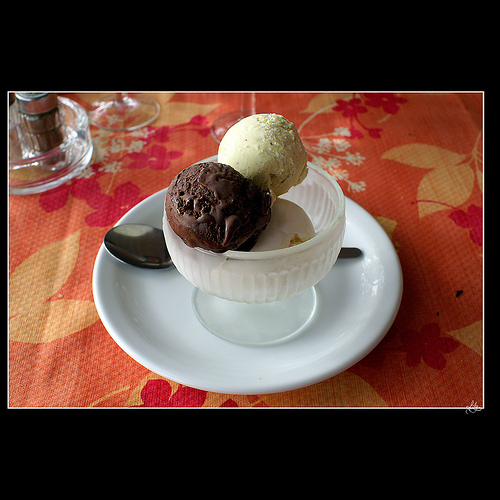<image>
Can you confirm if the food is on the bowel? Yes. Looking at the image, I can see the food is positioned on top of the bowel, with the bowel providing support. Is there a spoon behind the plate? Yes. From this viewpoint, the spoon is positioned behind the plate, with the plate partially or fully occluding the spoon. 